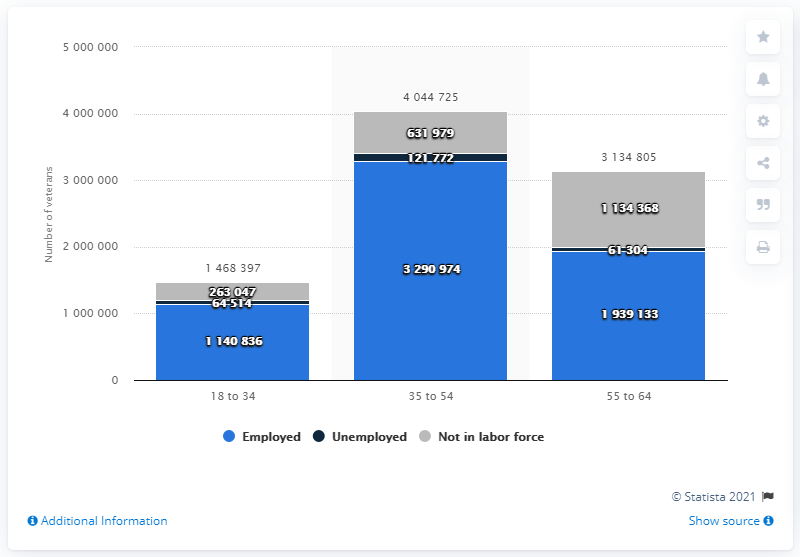Identify some key points in this picture. In 2019, there were approximately 3.29 million veterans who were employed in the United States. 